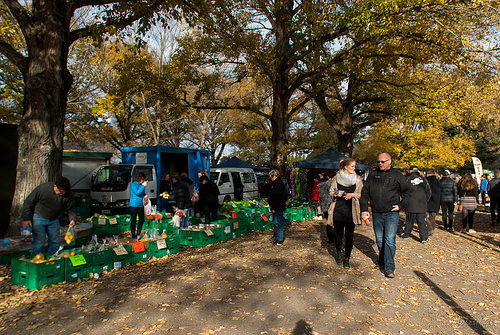<image>
Is the man to the left of the tree? No. The man is not to the left of the tree. From this viewpoint, they have a different horizontal relationship. 